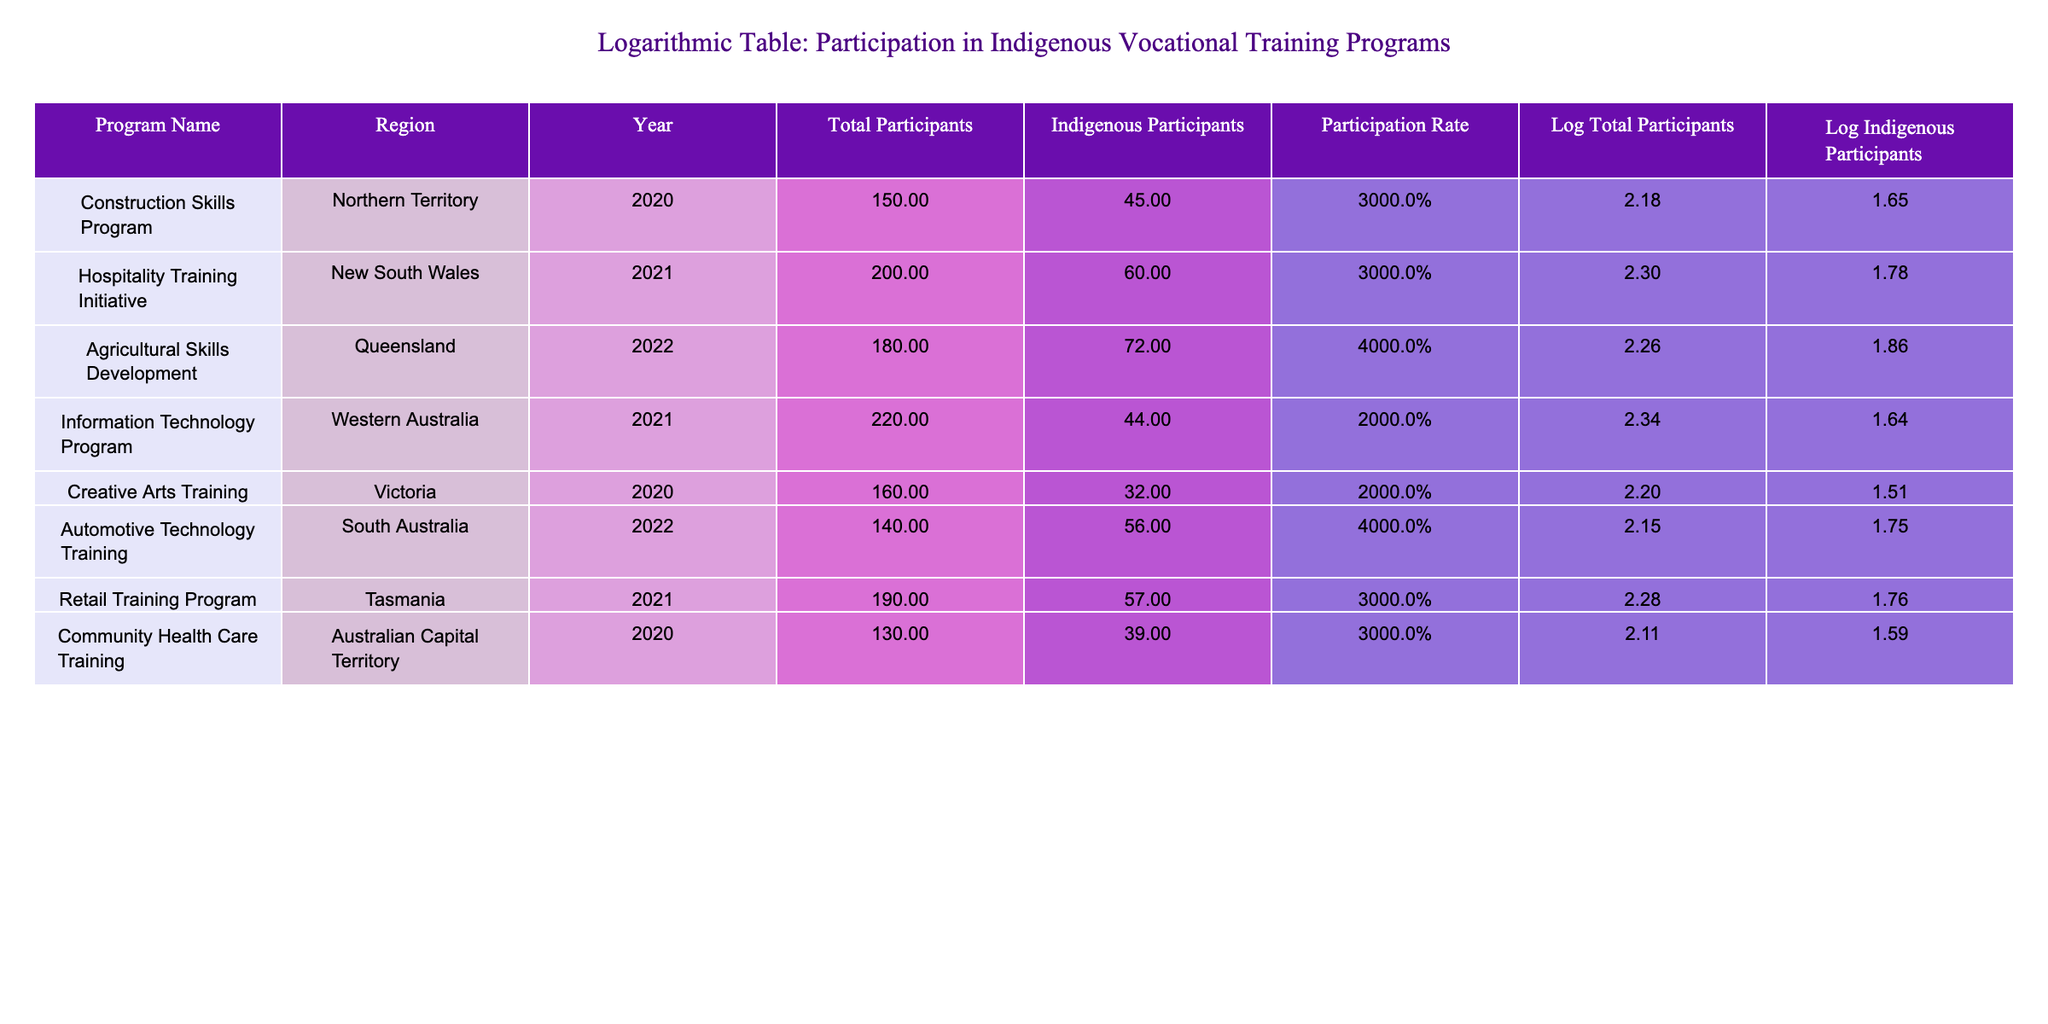What was the highest number of indigenous participants in a vocational training program? In the table, I can see the figures for Indigenous Participants for each program listed. The highest number is 72, which is from the Agricultural Skills Development in Queensland.
Answer: 72 Which region had the lowest participation rate in their vocational training program? By comparing the Participation Rates provided for each program, I can identify the lowest. The Information Technology Program in Western Australia has the lowest rate at 20%.
Answer: 20% What is the total number of participants across all programs? To find the total, I add the values for Total Participants from each row: 150 + 200 + 180 + 220 + 160 + 140 + 190 + 130 = 1,370.
Answer: 1370 Are there any programs where the indigenous participation rate exceeds 40%? Looking at the Participation Rates in the table, the Agricultural Skills Development and Automotive Technology Training programs both have rates exceeding 40%. Therefore, the answer is yes.
Answer: Yes What percentage of the total participants were indigenous participants in the Construction Skills Program? The Participation Rate for the Construction Skills Program is given as 30%. This means that 30% of the 150 total participants were indigenous participants, which is calculated directly from the given data.
Answer: 30% What is the average participation rate across all programs? I calculate the average by first summing the Participation Rates: 30 + 30 + 40 + 20 + 20 + 40 + 30 + 30 = 270. Then divide by the total number of programs, which is 8: 270 / 8 = 33.75%.
Answer: 33.75% In which program did the least number of total participants enroll, and how many participants were there? By reviewing the Total Participants for each program, the Automotive Technology Training has the least number with 140 participants.
Answer: Automotive Technology Training, 140 How many regions had a participation rate of 30% or higher? I can count the programs where the Participation Rate is 30% or above: Construction Skills, Hospitality Training, Agricultural Skills Development, Automotive Technology, Retail Training, and Community Health Care Training. There are 6 such programs.
Answer: 6 